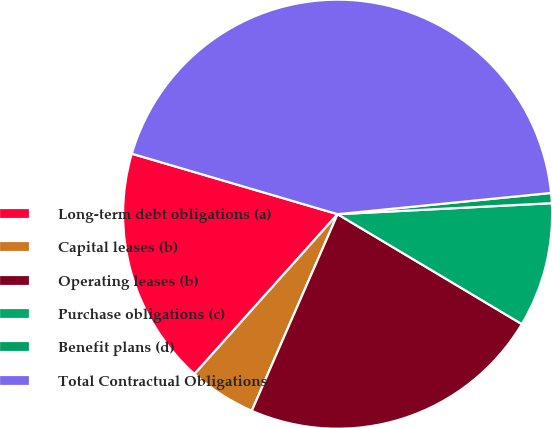<chart> <loc_0><loc_0><loc_500><loc_500><pie_chart><fcel>Long-term debt obligations (a)<fcel>Capital leases (b)<fcel>Operating leases (b)<fcel>Purchase obligations (c)<fcel>Benefit plans (d)<fcel>Total Contractual Obligations<nl><fcel>17.93%<fcel>5.07%<fcel>22.99%<fcel>9.38%<fcel>0.76%<fcel>43.87%<nl></chart> 